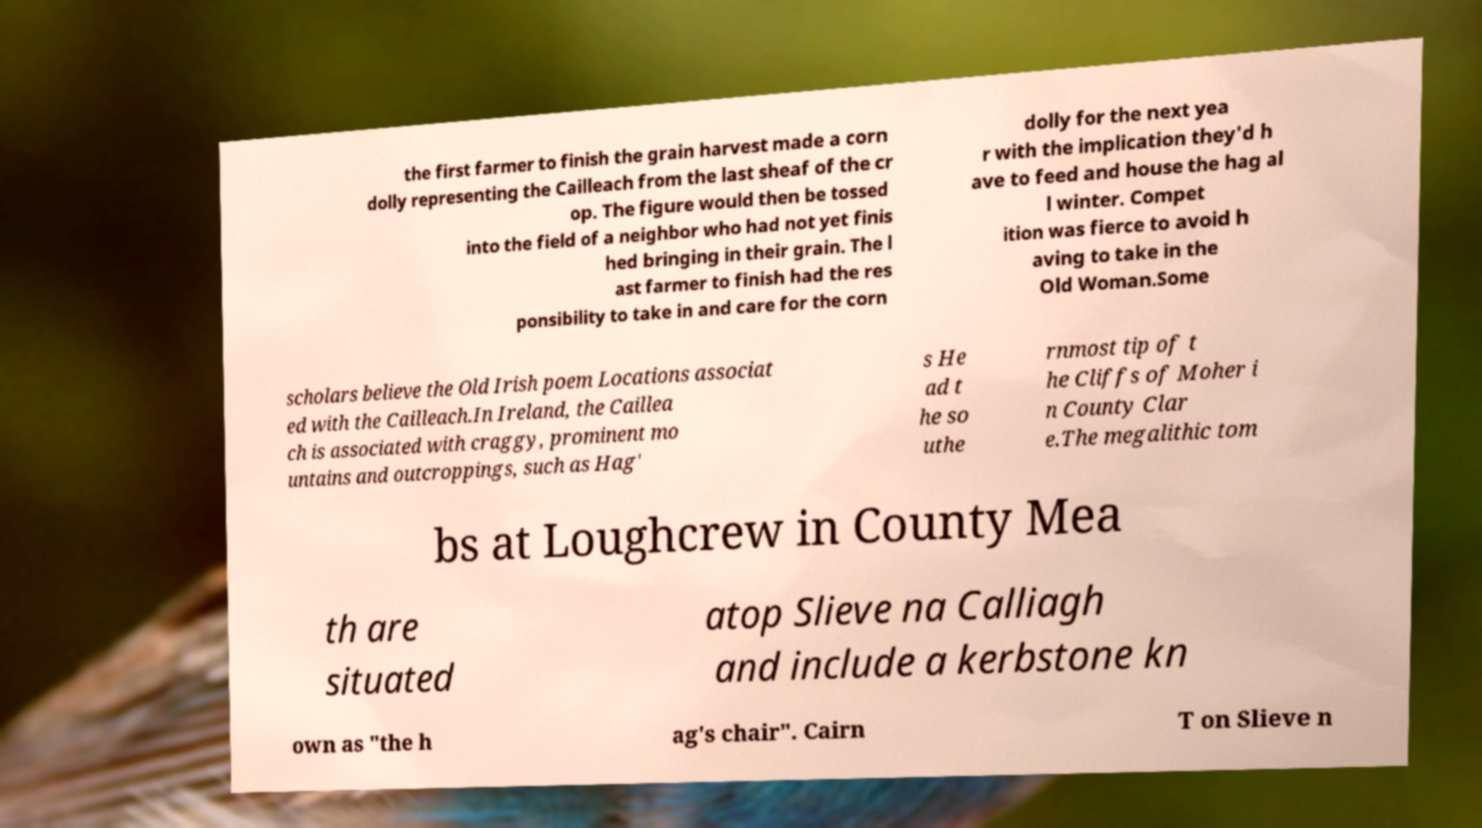Please identify and transcribe the text found in this image. the first farmer to finish the grain harvest made a corn dolly representing the Cailleach from the last sheaf of the cr op. The figure would then be tossed into the field of a neighbor who had not yet finis hed bringing in their grain. The l ast farmer to finish had the res ponsibility to take in and care for the corn dolly for the next yea r with the implication they'd h ave to feed and house the hag al l winter. Compet ition was fierce to avoid h aving to take in the Old Woman.Some scholars believe the Old Irish poem Locations associat ed with the Cailleach.In Ireland, the Caillea ch is associated with craggy, prominent mo untains and outcroppings, such as Hag' s He ad t he so uthe rnmost tip of t he Cliffs of Moher i n County Clar e.The megalithic tom bs at Loughcrew in County Mea th are situated atop Slieve na Calliagh and include a kerbstone kn own as "the h ag's chair". Cairn T on Slieve n 